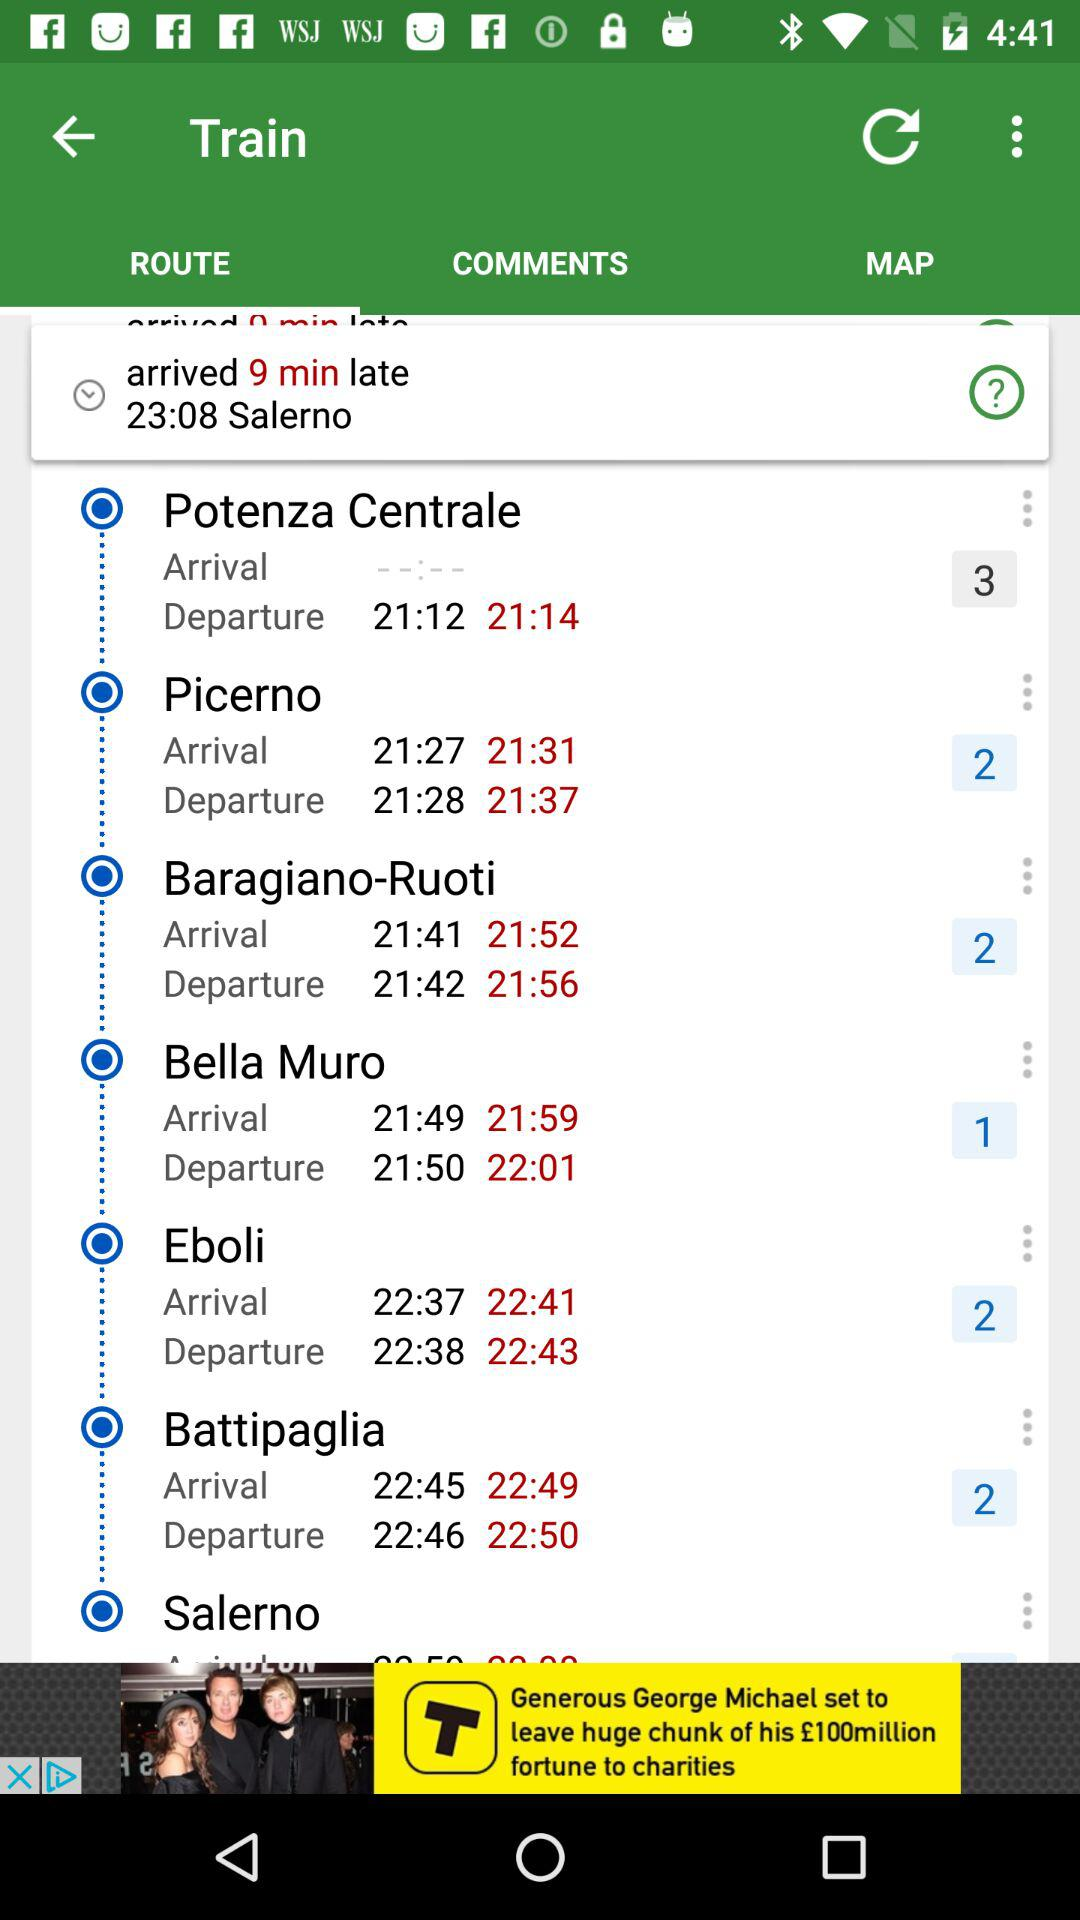What is the actual arrival time of the train at "Battipaglia"? The actual arrival time of the train at "Battipaglia" is 22:49. 